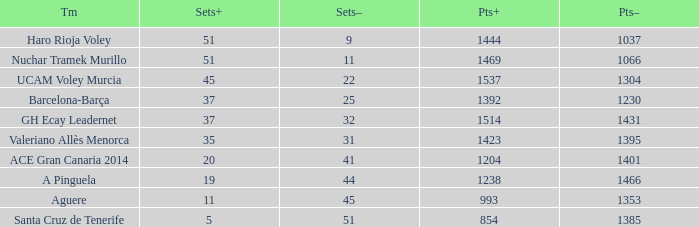What is the highest Points+ number that has a Sets+ number larger than 45, a Sets- number larger than 9, and a Points- number smaller than 1066? None. 